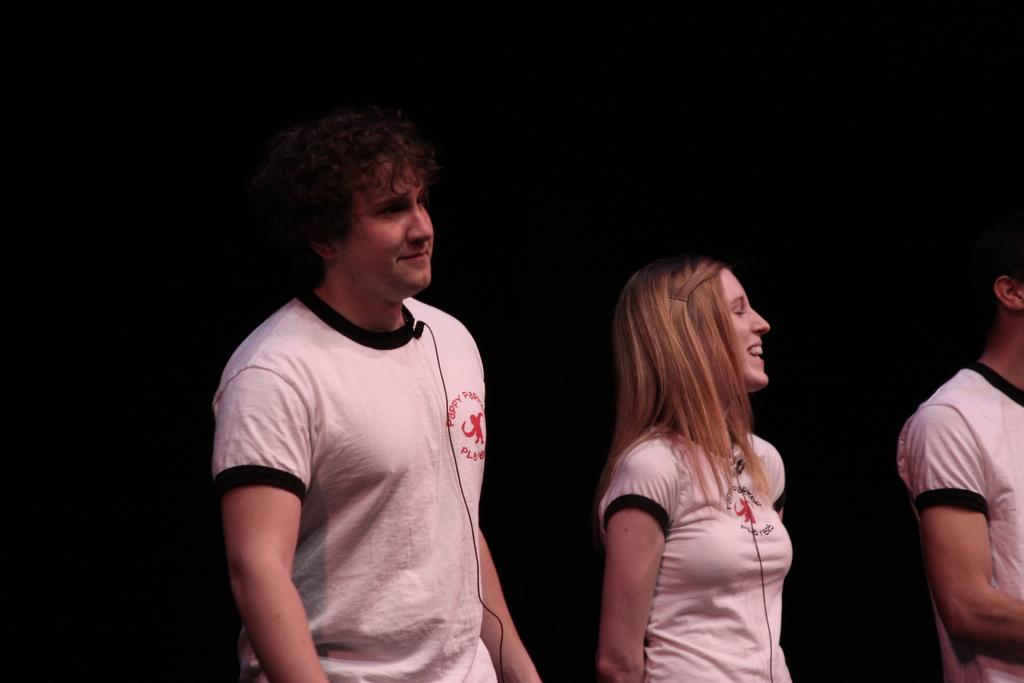How many people are in the image? There are three persons in the image. What are the people in the image doing? The three persons are standing. What type of clothing are the people wearing? Each person is wearing a t-shirt. What type of dime can be seen in the image? There is no dime present in the image. What material is the steel chair made of in the image? There is no chair, let alone a steel chair, present in the image. 